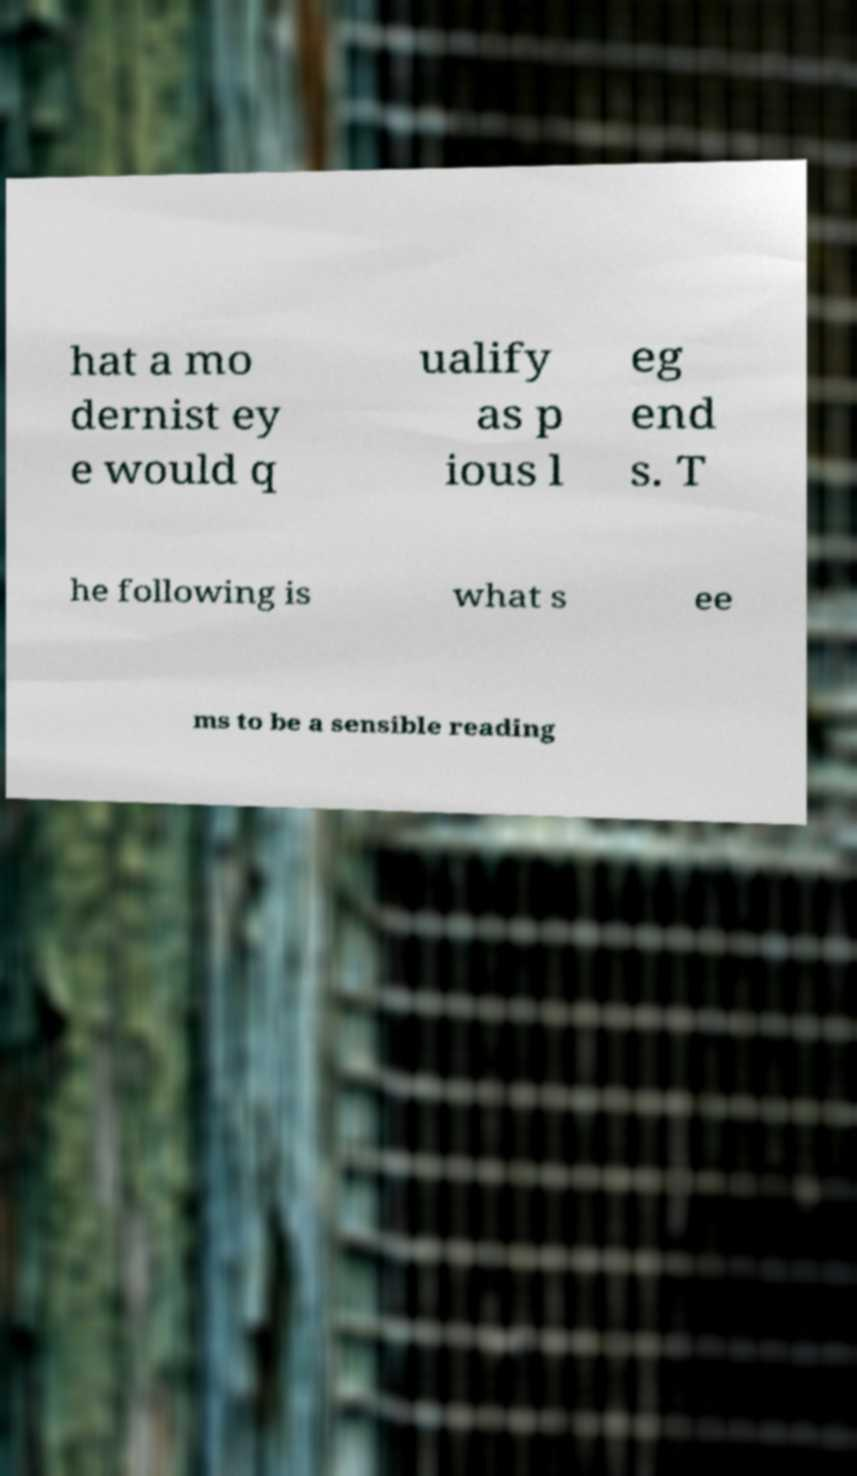Can you accurately transcribe the text from the provided image for me? hat a mo dernist ey e would q ualify as p ious l eg end s. T he following is what s ee ms to be a sensible reading 